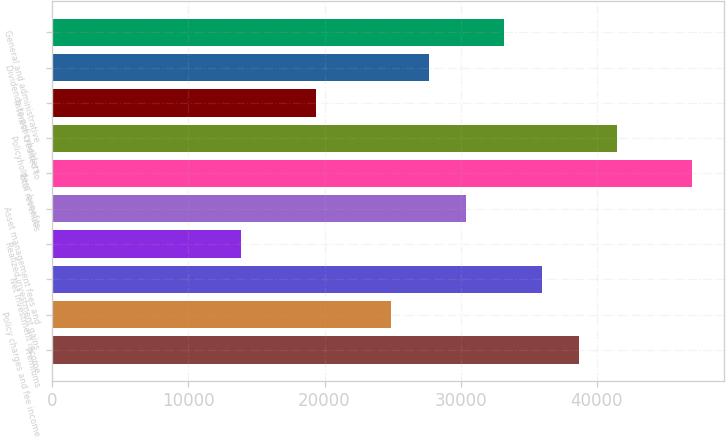Convert chart. <chart><loc_0><loc_0><loc_500><loc_500><bar_chart><fcel>Premiums<fcel>Policy charges and fee income<fcel>Net investment income<fcel>Realized investment gains<fcel>Asset management fees and<fcel>Total revenues<fcel>Policyholders' benefits<fcel>Interest credited to<fcel>Dividends to policyholders<fcel>General and administrative<nl><fcel>38726<fcel>24896<fcel>35960<fcel>13832<fcel>30428<fcel>47024<fcel>41492<fcel>19364<fcel>27662<fcel>33194<nl></chart> 